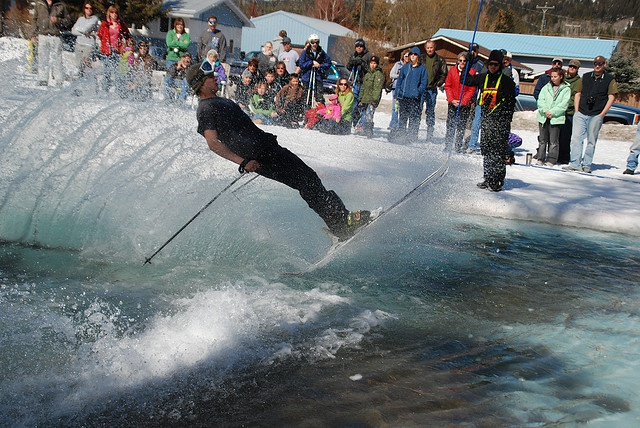Describe the objects in this image and their specific colors. I can see people in black, darkgray, gray, and lightgray tones, people in black, gray, maroon, and darkgray tones, people in black, gray, maroon, and navy tones, people in black, beige, gray, and aquamarine tones, and people in black, blue, navy, and gray tones in this image. 